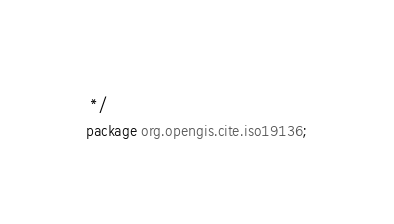Convert code to text. <code><loc_0><loc_0><loc_500><loc_500><_Java_> */
package org.opengis.cite.iso19136;</code> 